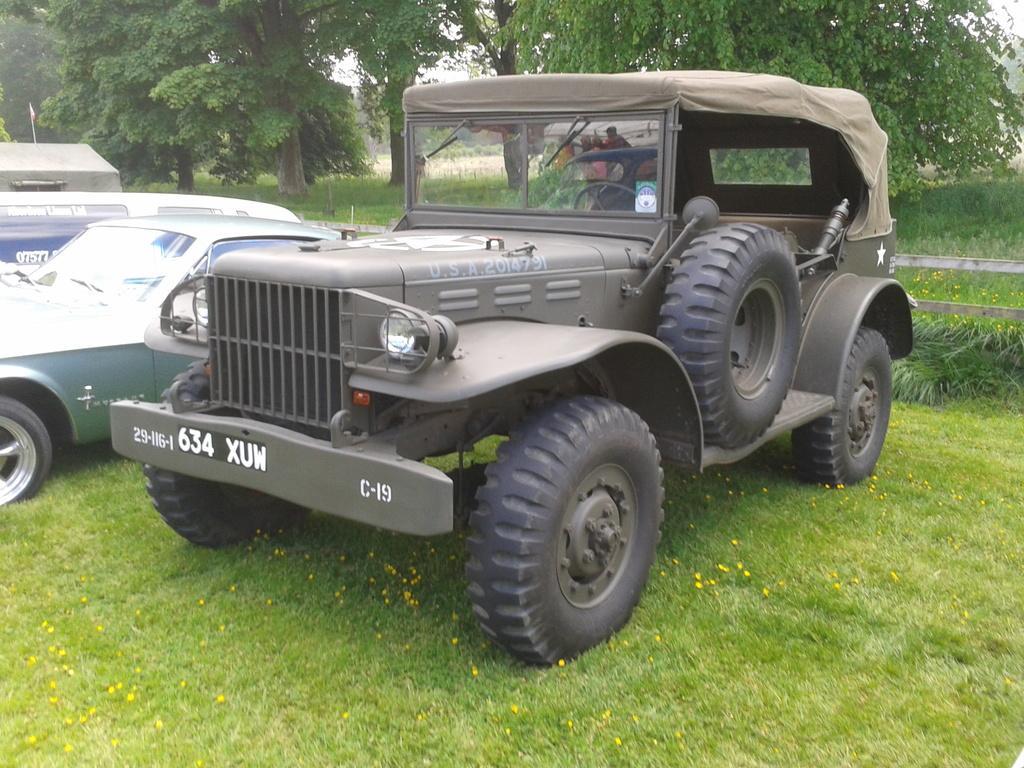Describe this image in one or two sentences. In this image in the foreground there's grass on the ground. In the middle there are vehicles and in the background there are trees and there is grass. 